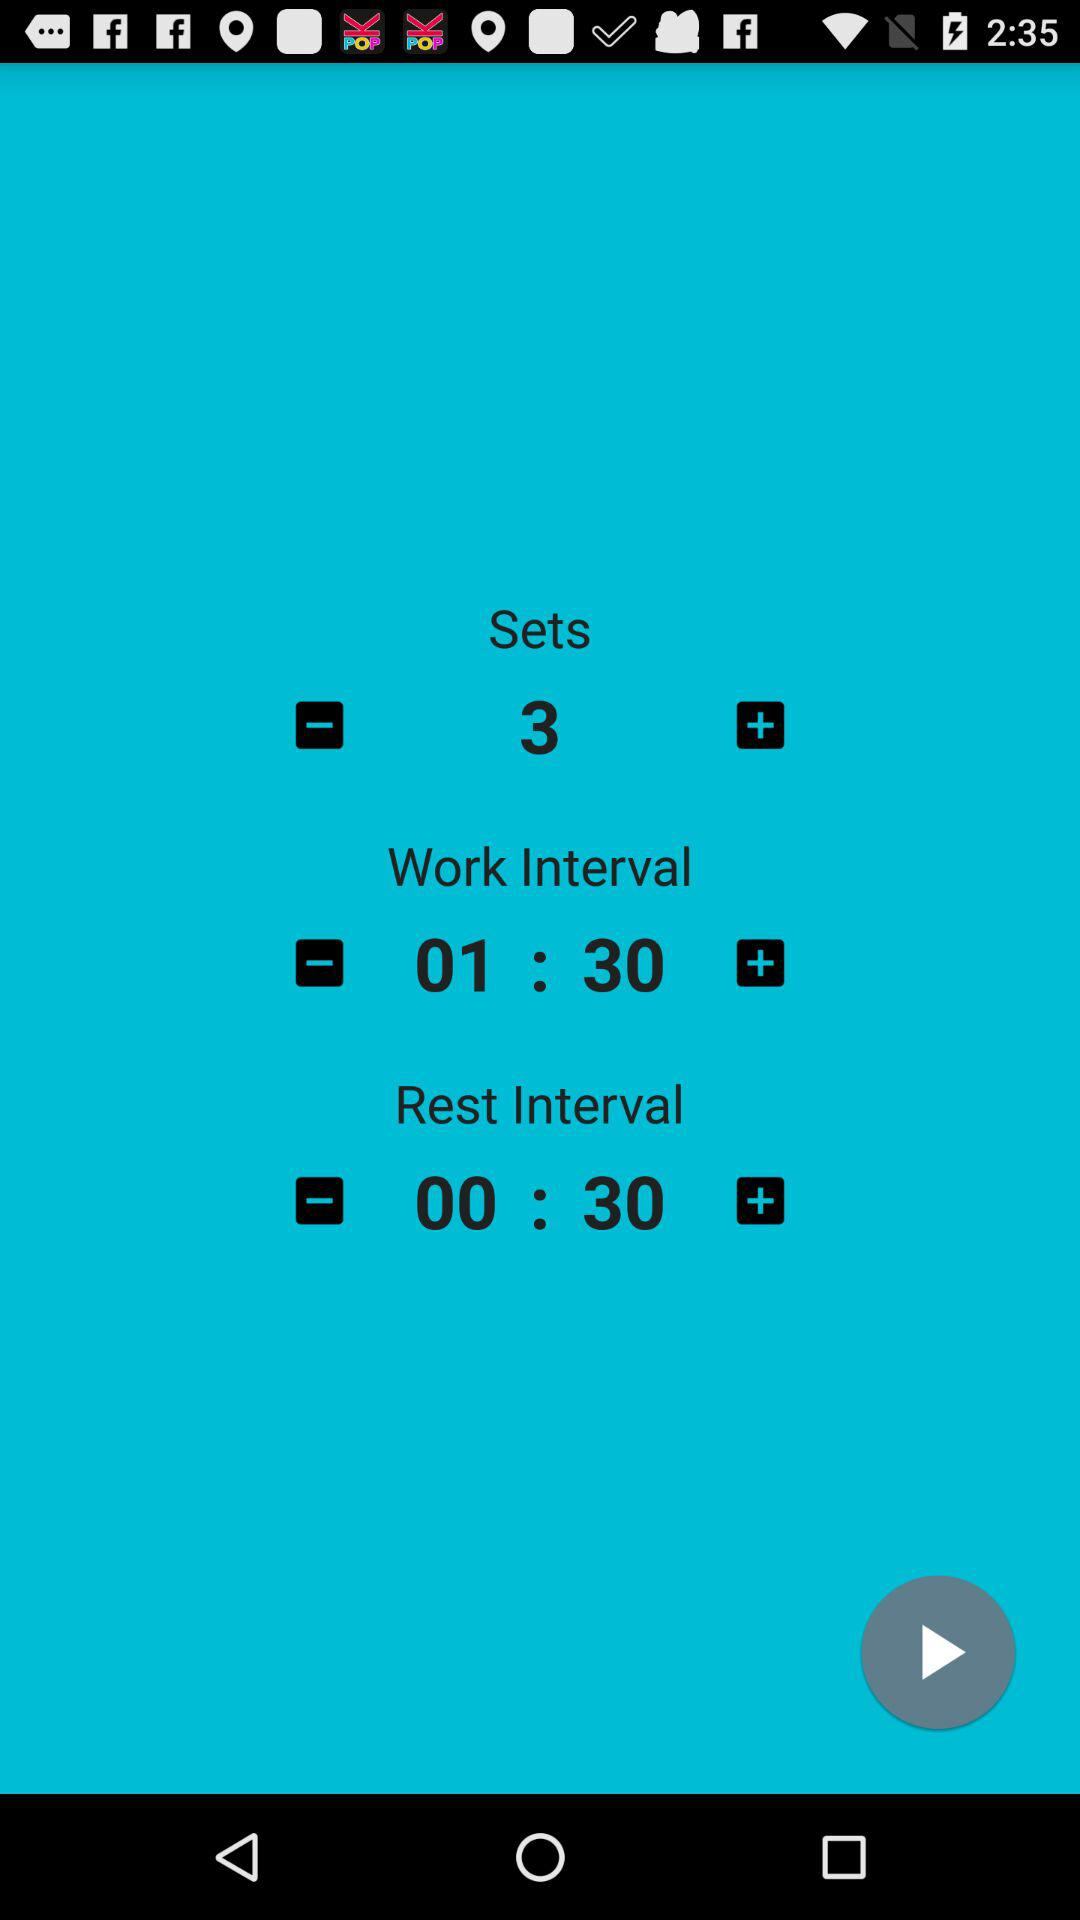What is the work interval time? The work interval time is 1:30. 